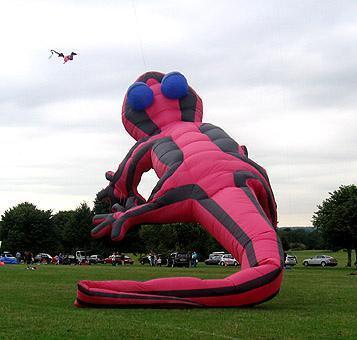How many balloons are in the air?
Give a very brief answer. 1. 